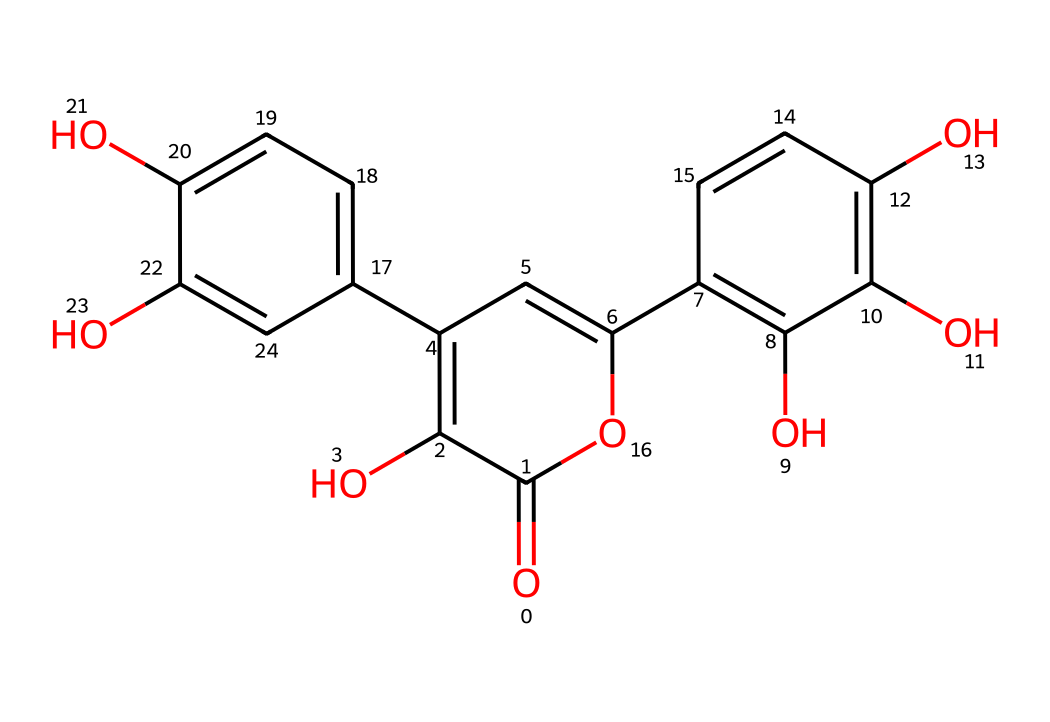How many rings are present in the structure of quercetin? The structure of quercetin features three interconnected aromatic rings, which are characteristic of flavonoids. By visually inspecting the SMILES representation, the distinct rings (specifically parts 1, 2, and 3 from the formula) can be counted.
Answer: three What is the primary functional group in quercetin? The primary functional group in quercetin is the hydroxyl group, represented by the "O" atoms bonded to carbon atoms in the structure. A thorough analysis of the structure shows multiple hydroxyl groups, which are vital for its antioxidant properties.
Answer: hydroxyl How many hydroxyl groups does quercetin contain? An examination of the structure reveals that there are five hydroxyl groups (indicated by "O" bonded to "H") located throughout the compound, contributing to its chemical properties. By counting each "O" connected to carbon within various rings, five can be confirmed.
Answer: five What type of compound is quercetin classified as? Quercetin is classified as a flavonoid, a class of polyphenolic compounds known for their antioxidant properties. The presence of the characteristic benzene rings and multiple hydroxyl groups confirms this classification within the broader realm of aromatic compounds.
Answer: flavonoid Does quercetin have any double bonds in its structure? Yes, quercetin has several double bonds (indicated by the alternating "C=C" notations in the SMILES representation), present within the aromatic rings. The structure's benzene rings are essential for such bond configurations.
Answer: yes How many carbon atoms are present in quercetin? Counting the number of carbon atoms in the structure shows that there are 15 carbon atoms present in total. By breaking down the structural formula into its constituent parts, each carbon can be tallied.
Answer: 15 